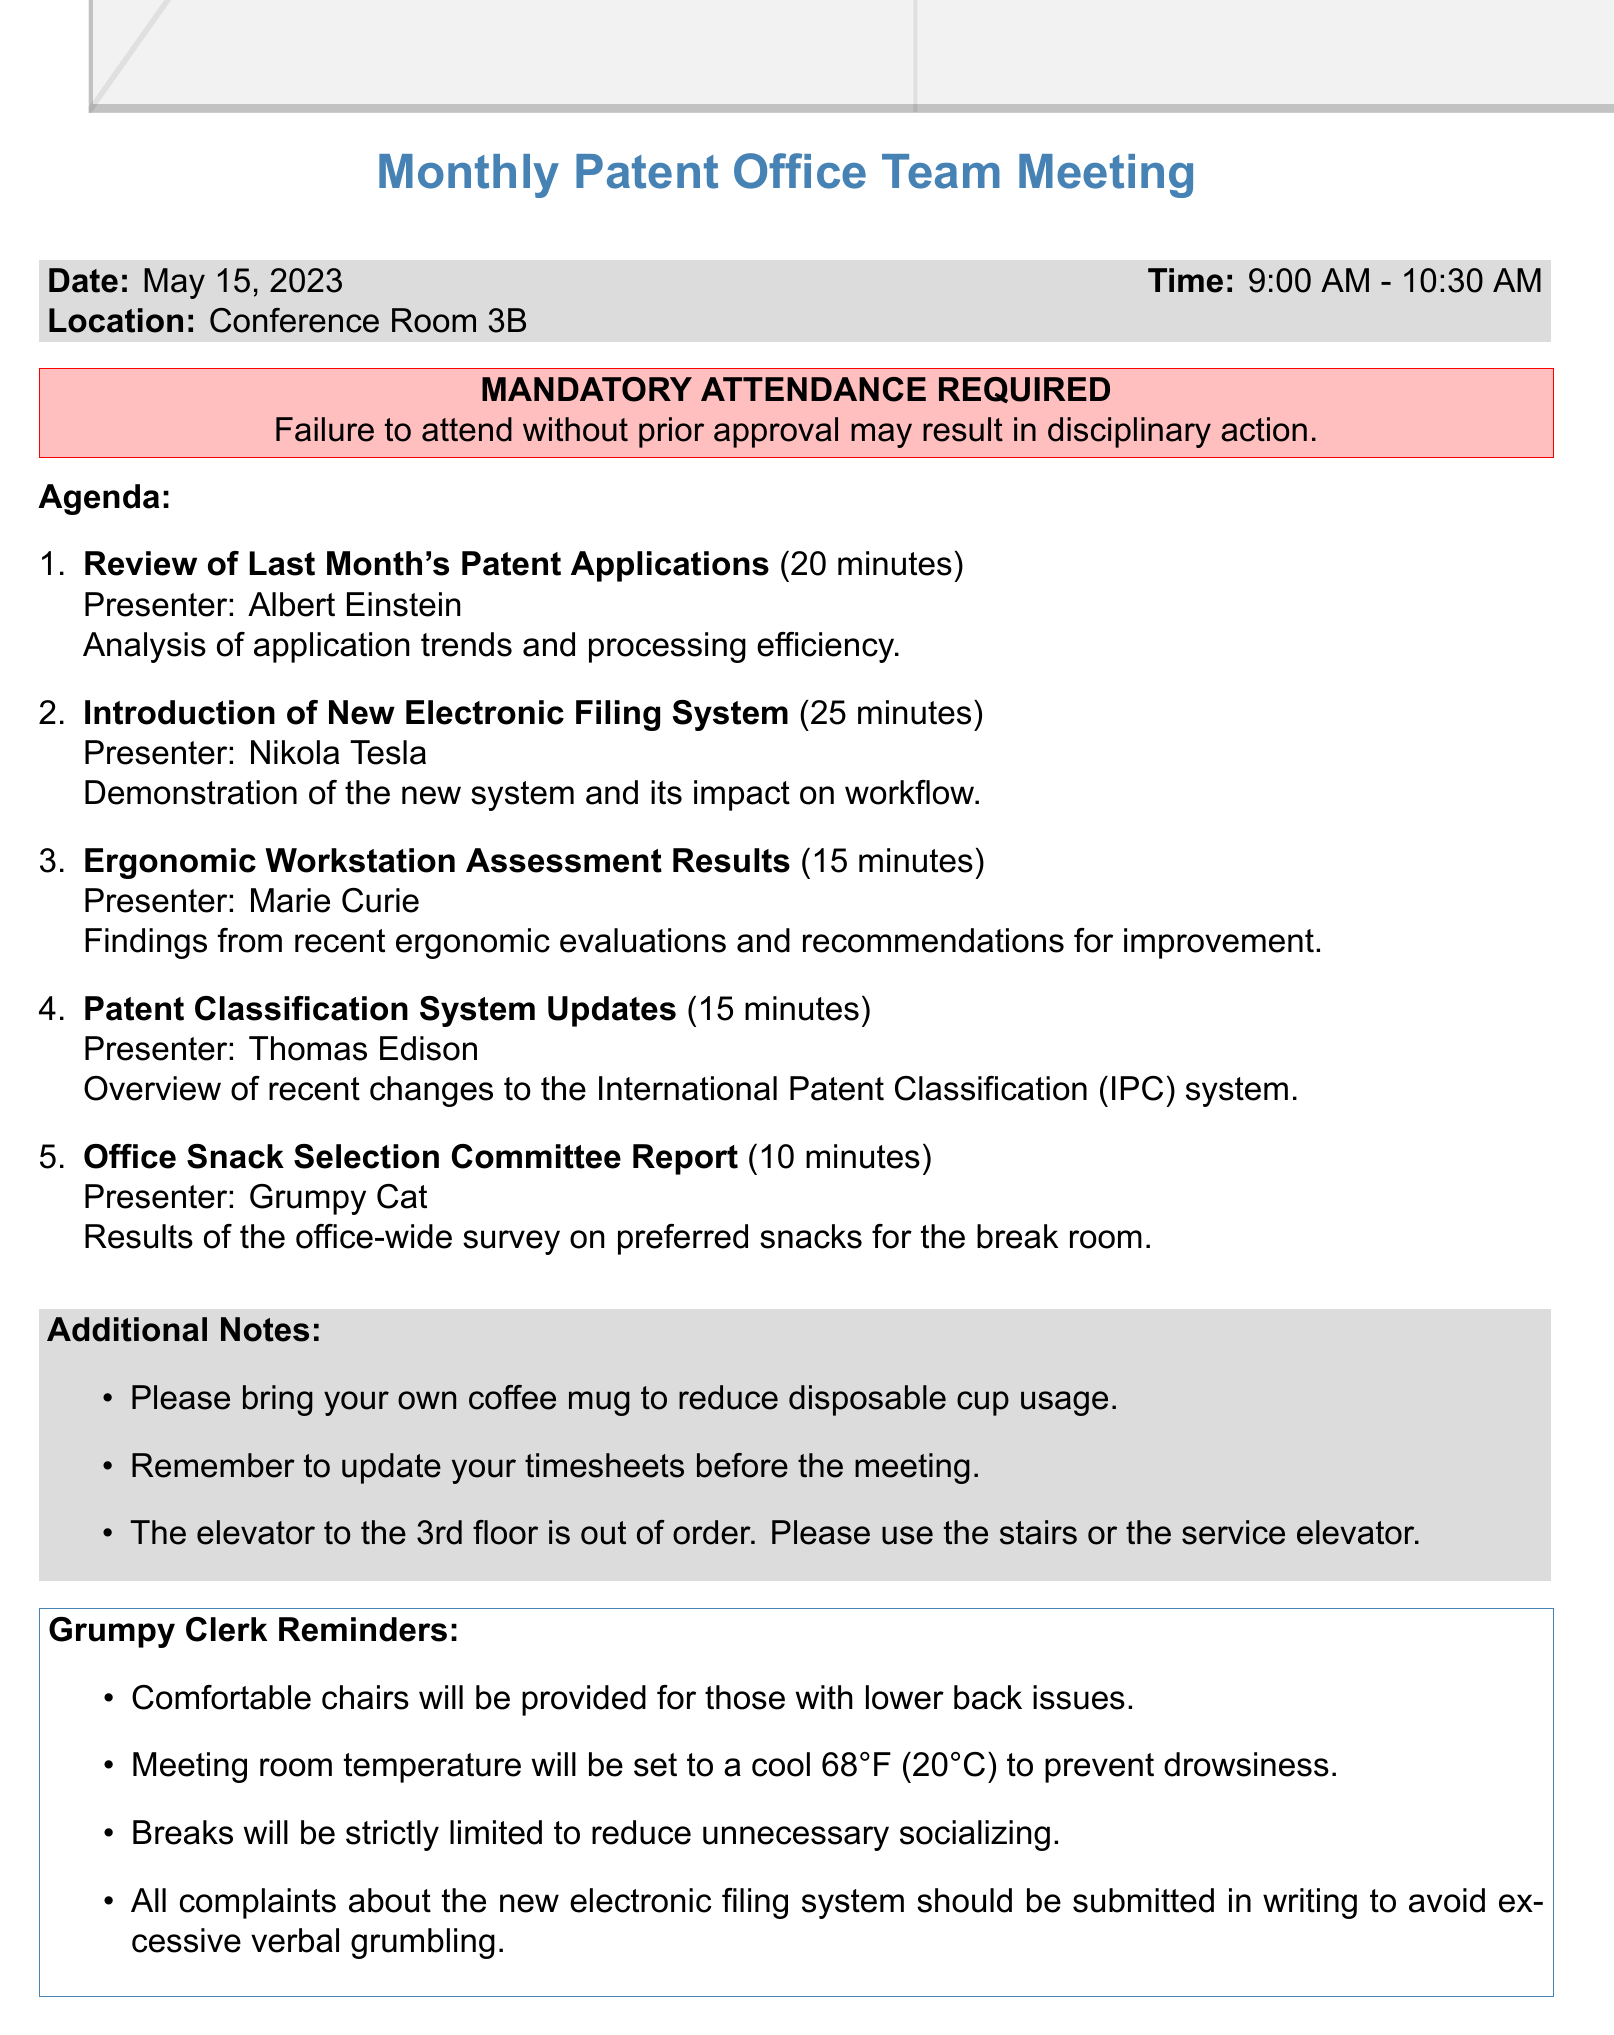What is the date of the meeting? The date of the meeting is explicitly mentioned in the document under meeting details.
Answer: May 15, 2023 Who is presenting the introductory session on the new electronic filing system? The presenter of this session is identified in the agenda item for the electronic filing system.
Answer: Nikola Tesla How long is the session about ergonomic workstation assessment results? The duration is specified beside the agenda item's title concerning ergonomic workstation assessment results.
Answer: 15 minutes What is required to attend the meeting? The document clearly states the requirement related to attendance within the attendance reminder section.
Answer: MANDATORY ATTENDANCE REQUIRED What is the temperature set for the meeting room? The setting for the meeting room temperature is listed as a reminder in the grumpy clerk reminders.
Answer: 68°F (20°C) What is the location of the meeting? The location is mentioned directly under the meeting details in the document.
Answer: Conference Room 3B What committee is reporting on office snacks? This specific item is detailed in the agenda, indicating who is responsible for the report.
Answer: Office Snack Selection Committee How many minutes is allocated for reviewing last month's patent applications? The time allocated for this agenda item is stated directly next to the agenda title.
Answer: 20 minutes 